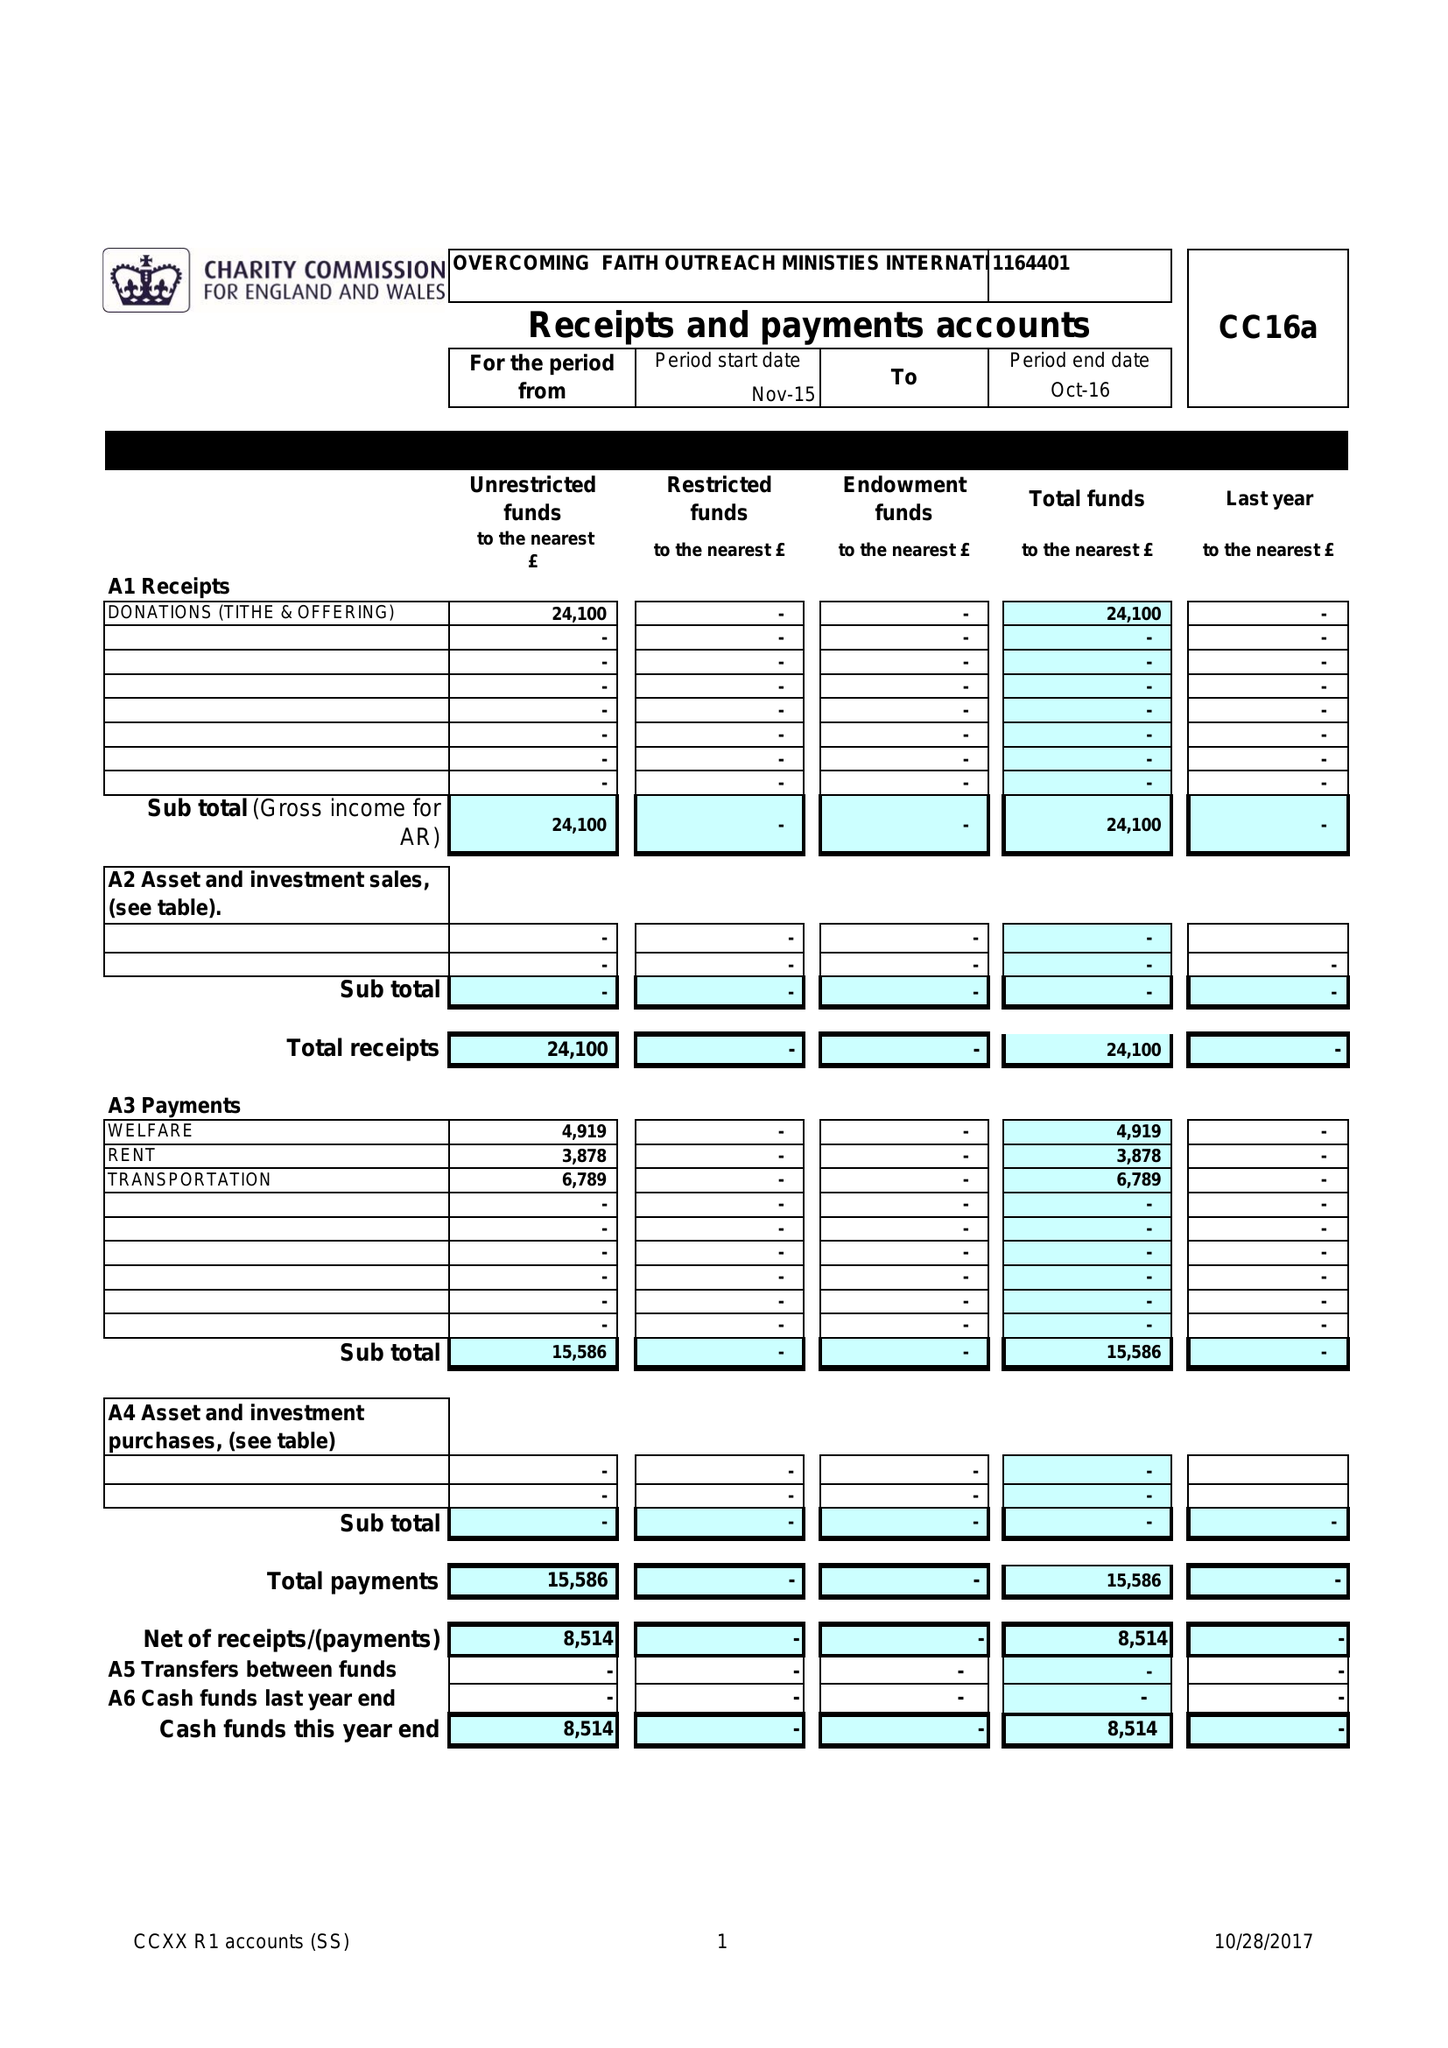What is the value for the address__street_line?
Answer the question using a single word or phrase. None 